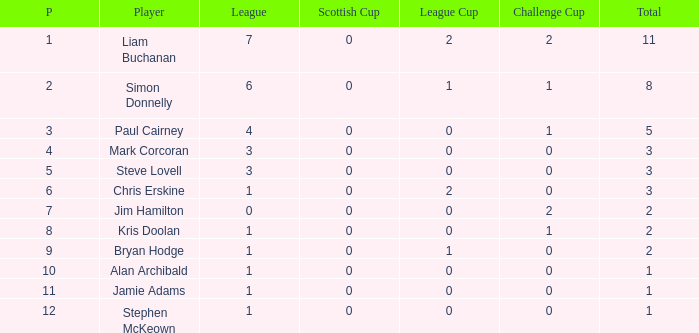How many points did player 7 score in the challenge cup? 1.0. 